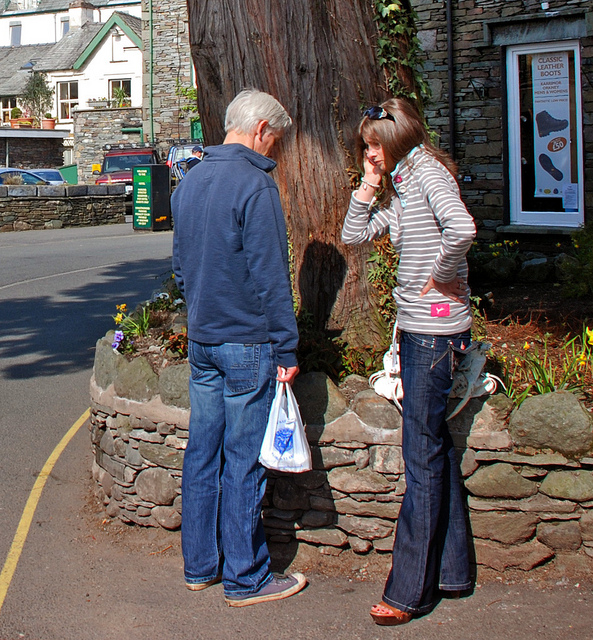<image>What type of flowers are in the picture? I don't know what type of flowers are in the picture. It can be sunflowers, pansies, lilies, daffodils, tulips or geraniums. Where are three brown pots? I don't know where the three brown pots are. They might be on a planter, wall, or background. However, they might not be present at all. Where are three brown pots? I don't know where the three brown pots are. There are no visible brown pots in the image. What type of flowers are in the picture? I don't know what type of flowers are in the picture. It can be seen 'sunflowers', 'pansies', 'lilies', 'daffodils', 'tulips' or 'geraniums'. 